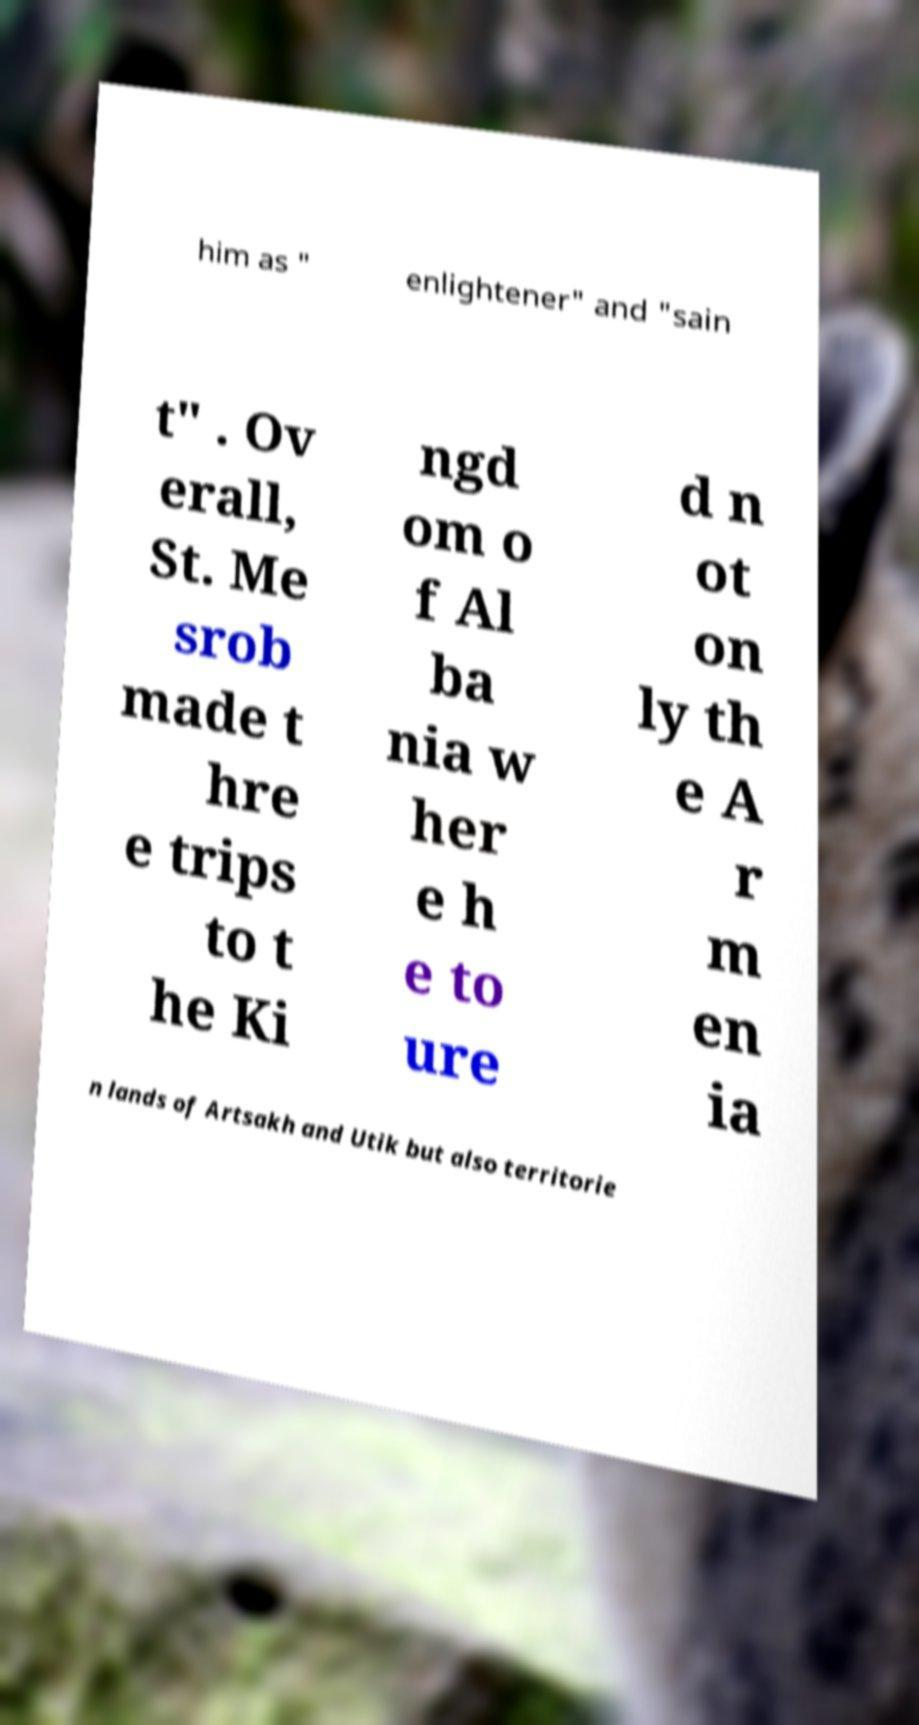Can you read and provide the text displayed in the image?This photo seems to have some interesting text. Can you extract and type it out for me? him as " enlightener" and "sain t" . Ov erall, St. Me srob made t hre e trips to t he Ki ngd om o f Al ba nia w her e h e to ure d n ot on ly th e A r m en ia n lands of Artsakh and Utik but also territorie 